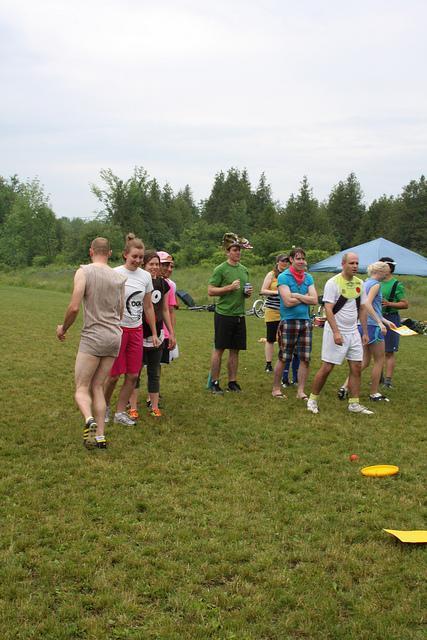How many people are in this picture?
Give a very brief answer. 10. How many people are not wearing shorts?
Give a very brief answer. 1. How many people are there?
Give a very brief answer. 7. 